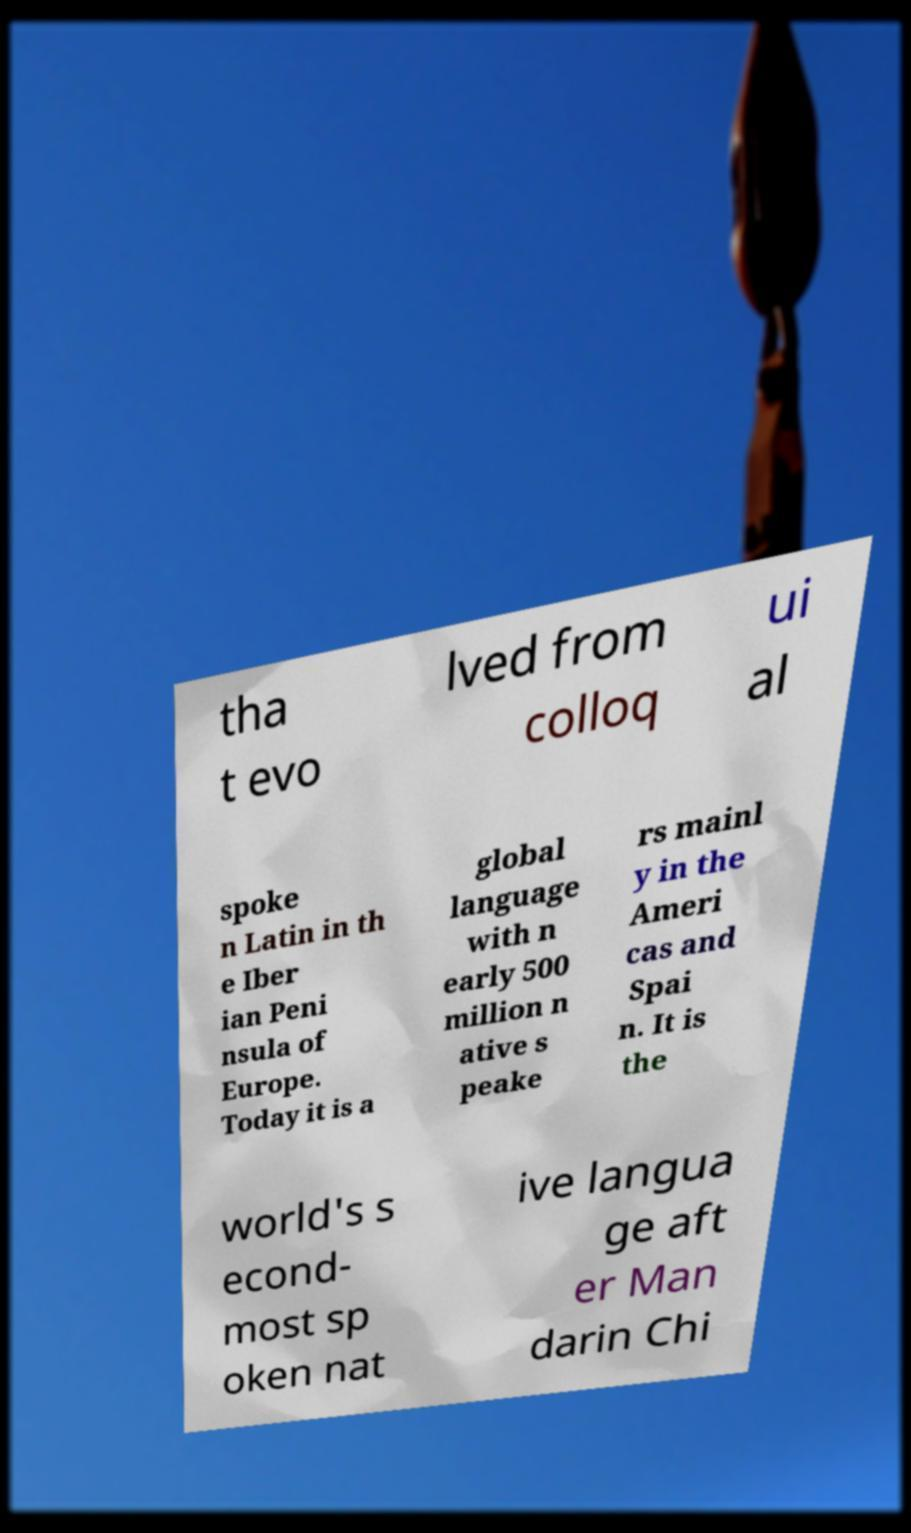Could you extract and type out the text from this image? tha t evo lved from colloq ui al spoke n Latin in th e Iber ian Peni nsula of Europe. Today it is a global language with n early 500 million n ative s peake rs mainl y in the Ameri cas and Spai n. It is the world's s econd- most sp oken nat ive langua ge aft er Man darin Chi 